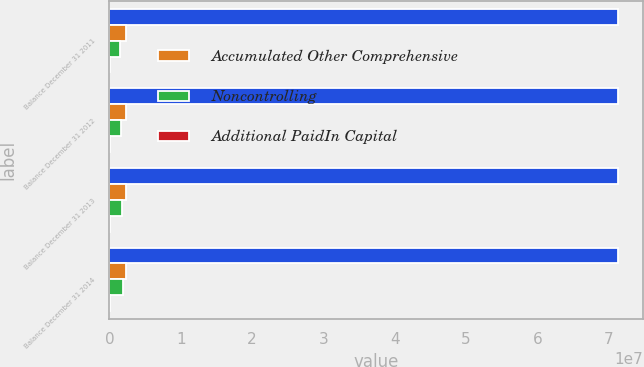Convert chart to OTSL. <chart><loc_0><loc_0><loc_500><loc_500><stacked_bar_chart><ecel><fcel>Balance December 31 2011<fcel>Balance December 31 2012<fcel>Balance December 31 2013<fcel>Balance December 31 2014<nl><fcel>nan<fcel>7.12649e+07<fcel>7.12649e+07<fcel>7.12649e+07<fcel>7.12649e+07<nl><fcel>Accumulated Other Comprehensive<fcel>2.3797e+06<fcel>2.3797e+06<fcel>2.3797e+06<fcel>2.3797e+06<nl><fcel>Noncontrolling<fcel>1.51074e+06<fcel>1.62424e+06<fcel>1.8044e+06<fcel>1.96872e+06<nl><fcel>Additional PaidIn Capital<fcel>125591<fcel>89095<fcel>53372<fcel>48333<nl></chart> 